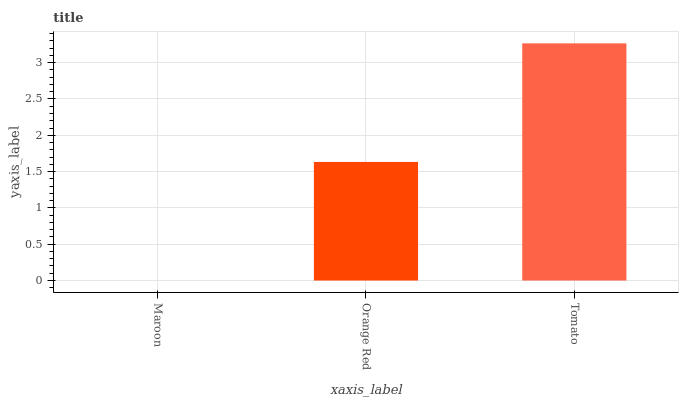Is Maroon the minimum?
Answer yes or no. Yes. Is Tomato the maximum?
Answer yes or no. Yes. Is Orange Red the minimum?
Answer yes or no. No. Is Orange Red the maximum?
Answer yes or no. No. Is Orange Red greater than Maroon?
Answer yes or no. Yes. Is Maroon less than Orange Red?
Answer yes or no. Yes. Is Maroon greater than Orange Red?
Answer yes or no. No. Is Orange Red less than Maroon?
Answer yes or no. No. Is Orange Red the high median?
Answer yes or no. Yes. Is Orange Red the low median?
Answer yes or no. Yes. Is Maroon the high median?
Answer yes or no. No. Is Tomato the low median?
Answer yes or no. No. 